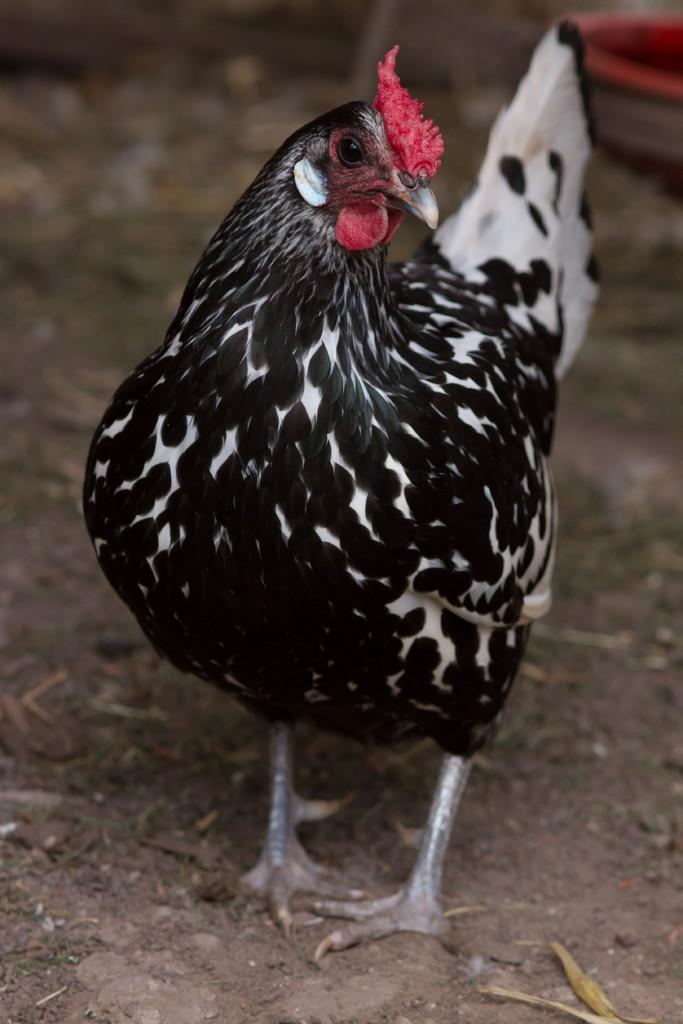What type of animal is in the image? There is a hen in the image. What color is the hen in the image? The hen is in black and white color. What type of lumber is the hen using for its hobbies in the image? There is no lumber or hobbies mentioned in the image; it only features a black and white hen. 